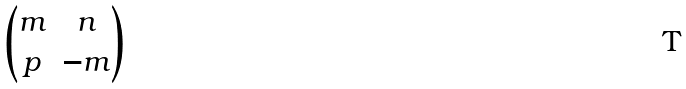<formula> <loc_0><loc_0><loc_500><loc_500>\begin{pmatrix} m & n \\ p & - m \\ \end{pmatrix}</formula> 